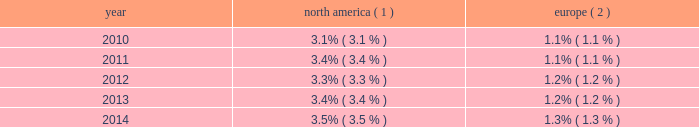Royal caribbean cruises ltd .
15 from two to 17 nights throughout south america , the caribbean and europe .
Additionally , we announced that majesty of the seas will be redeployed from royal caribbean international to pullmantur in 2016 .
Pullmantur serves the contemporary segment of the spanish , portuguese and latin american cruise mar- kets .
Pullmantur 2019s strategy is to attract cruise guests from these target markets by providing a variety of cruising options and onboard activities directed at couples and families traveling with children .
Over the last few years , pullmantur has systematically increased its focus on latin america and has expanded its pres- ence in that market .
In order to facilitate pullmantur 2019s ability to focus on its core cruise business , on march 31 , 2014 , pullmantur sold the majority of its interest in its non-core busi- nesses .
These non-core businesses included pullmantur 2019s land-based tour operations , travel agency and 49% ( 49 % ) interest in its air business .
In connection with the sale agreement , we retained a 19% ( 19 % ) interest in each of the non-core businesses as well as 100% ( 100 % ) ownership of the aircraft which are being dry leased to pullmantur air .
See note 1 .
General and note 6 .
Other assets to our consolidated financial statements under item 8 .
Financial statements and supplementary data for further details .
Cdf croisi e8res de france we currently operate two ships with an aggregate capacity of approximately 2800 berths under our cdf croisi e8res de france brand .
Cdf croisi e8res de france offers seasonal itineraries to the mediterranean , europe and caribbean .
During the winter season , zenith is deployed to the pullmantur brand for sailings in south america .
Cdf croisi e8res de france is designed to serve the contemporary segment of the french cruise market by providing a brand tailored for french cruise guests .
Tui cruises tui cruises is a joint venture owned 50% ( 50 % ) by us and 50% ( 50 % ) by tui ag , a german tourism and shipping com- pany , and is designed to serve the contemporary and premium segments of the german cruise market by offering a product tailored for german guests .
All onboard activities , services , shore excursions and menu offerings are designed to suit the preferences of this target market .
Tui cruises operates three ships , mein schiff 1 , mein schiff 2 and mein schiff 3 , with an aggregate capacity of approximately 6300 berths .
In addition , tui cruises currently has three newbuild ships on order at the finnish meyer turku yard with an aggregate capacity of approximately 7500 berths : mein schiff 4 , scheduled for delivery in the second quarter of 2015 , mein schiff 5 , scheduled for delivery in the third quarter of 2016 and mein schiff 6 , scheduled for delivery in the second quarter of 2017 .
In november 2014 , we formed a strategic partnership with ctrip.com international ltd .
( 201cctrip 201d ) , a chinese travel service provider , to operate a new cruise brand known as skysea cruises .
Skysea cruises will offer a custom-tailored product for chinese cruise guests operating the ship purchased from celebrity cruises .
The new cruise line will begin service in the second quarter of 2015 .
We and ctrip each own 35% ( 35 % ) of the new company , skysea holding , with the balance being owned by skysea holding management and a private equity fund .
Industry cruising is considered a well-established vacation sector in the north american market , a growing sec- tor over the long term in the european market and a developing but promising sector in several other emerging markets .
Industry data indicates that market penetration rates are still low and that a significant portion of cruise guests carried are first-time cruisers .
We believe this presents an opportunity for long-term growth and a potential for increased profitability .
The table details market penetration rates for north america and europe computed based on the number of annual cruise guests as a percentage of the total population : america ( 1 ) europe ( 2 ) .
( 1 ) source : our estimates are based on a combination of data obtained from publicly available sources including the interna- tional monetary fund and cruise lines international association ( 201cclia 201d ) .
Rates are based on cruise guests carried for at least two consecutive nights .
Includes the united states of america and canada .
( 2 ) source : our estimates are based on a combination of data obtained from publicly available sources including the interna- tional monetary fund and clia europe , formerly european cruise council .
We estimate that the global cruise fleet was served by approximately 457000 berths on approximately 283 ships at the end of 2014 .
There are approximately 33 ships with an estimated 98650 berths that are expected to be placed in service in the global cruise market between 2015 and 2019 , although it is also possible that ships could be ordered or taken out of service during these periods .
We estimate that the global cruise industry carried 22.0 million cruise guests in 2014 compared to 21.3 million cruise guests carried in 2013 and 20.9 million cruise guests carried in 2012 .
Part i .
What was the percentage increase in the cruise guests from 2013 to 2014? 
Computations: ((22.0 - 21.3) / 21.3)
Answer: 0.03286. 